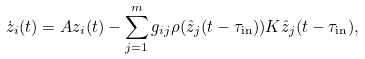Convert formula to latex. <formula><loc_0><loc_0><loc_500><loc_500>\dot { z } _ { i } ( t ) = A z _ { i } ( t ) - \sum _ { j = 1 } ^ { m } g _ { i j } \rho ( \hat { z } _ { j } ( t - \tau _ { \text {in} } ) ) K \hat { z } _ { j } ( t - \tau _ { \text {in} } ) ,</formula> 